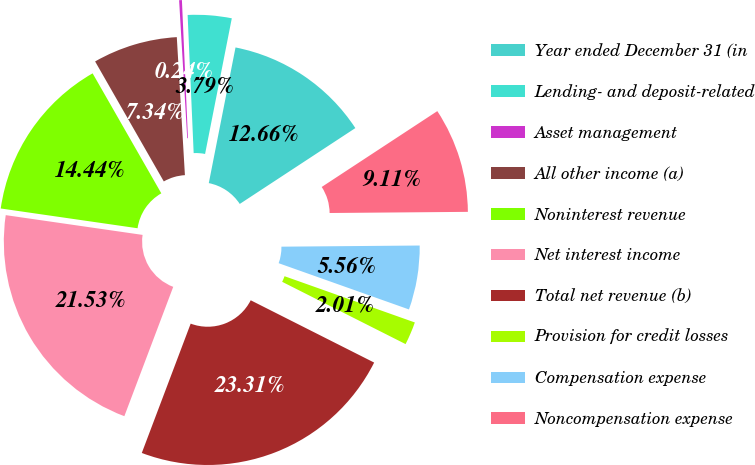<chart> <loc_0><loc_0><loc_500><loc_500><pie_chart><fcel>Year ended December 31 (in<fcel>Lending- and deposit-related<fcel>Asset management<fcel>All other income (a)<fcel>Noninterest revenue<fcel>Net interest income<fcel>Total net revenue (b)<fcel>Provision for credit losses<fcel>Compensation expense<fcel>Noncompensation expense<nl><fcel>12.66%<fcel>3.79%<fcel>0.24%<fcel>7.34%<fcel>14.44%<fcel>21.53%<fcel>23.31%<fcel>2.01%<fcel>5.56%<fcel>9.11%<nl></chart> 